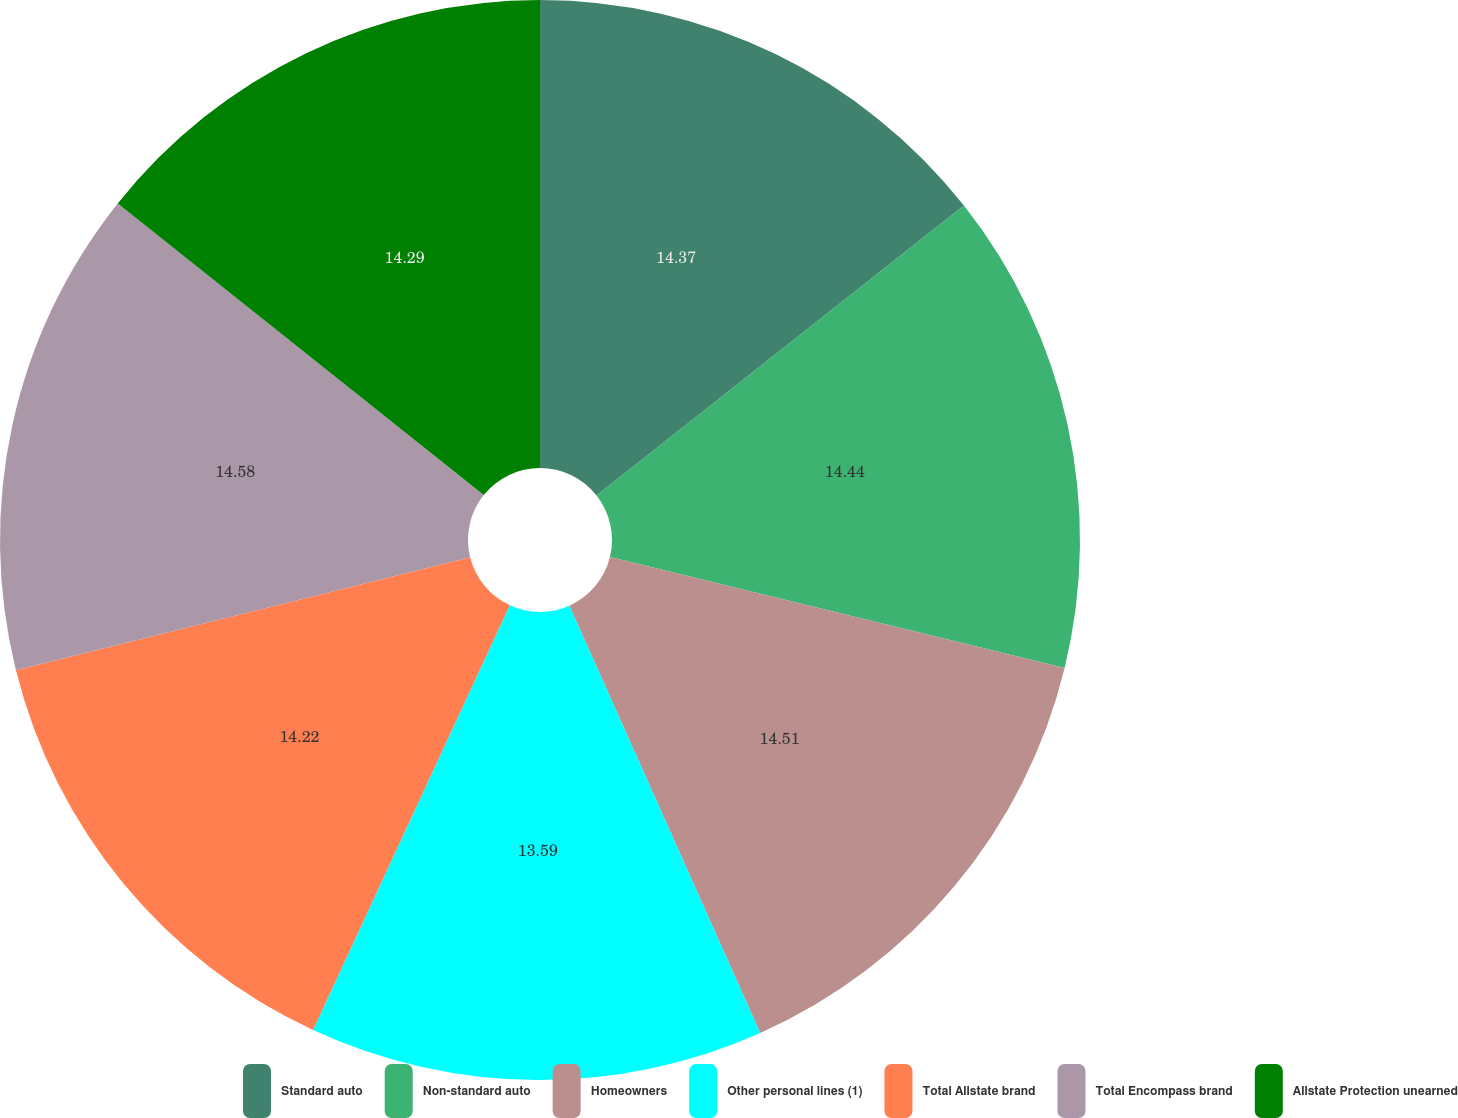Convert chart. <chart><loc_0><loc_0><loc_500><loc_500><pie_chart><fcel>Standard auto<fcel>Non-standard auto<fcel>Homeowners<fcel>Other personal lines (1)<fcel>Total Allstate brand<fcel>Total Encompass brand<fcel>Allstate Protection unearned<nl><fcel>14.37%<fcel>14.44%<fcel>14.51%<fcel>13.59%<fcel>14.22%<fcel>14.59%<fcel>14.29%<nl></chart> 